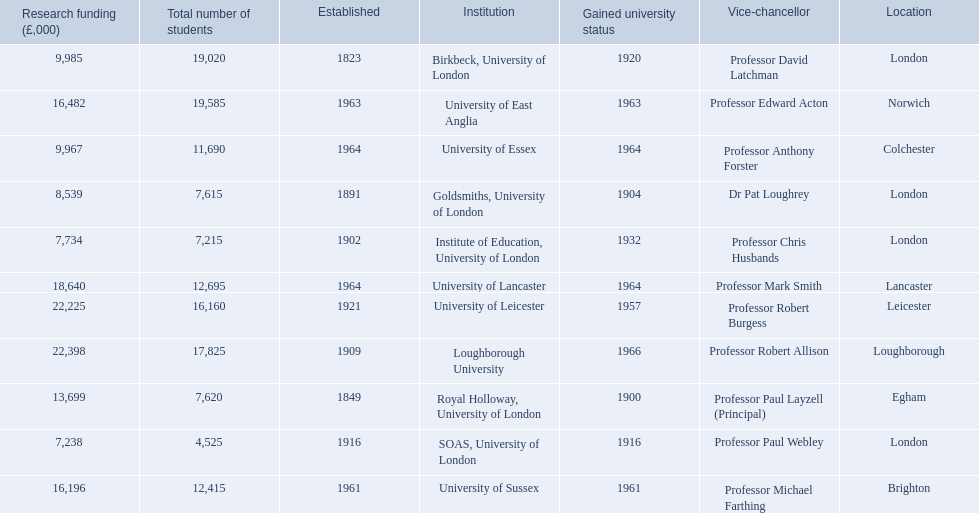What are the institutions in the 1994 group? Birkbeck, University of London, University of East Anglia, University of Essex, Goldsmiths, University of London, Institute of Education, University of London, University of Lancaster, University of Leicester, Loughborough University, Royal Holloway, University of London, SOAS, University of London, University of Sussex. Parse the full table in json format. {'header': ['Research funding (£,000)', 'Total number of students', 'Established', 'Institution', 'Gained university status', 'Vice-chancellor', 'Location'], 'rows': [['9,985', '19,020', '1823', 'Birkbeck, University of London', '1920', 'Professor David Latchman', 'London'], ['16,482', '19,585', '1963', 'University of East Anglia', '1963', 'Professor Edward Acton', 'Norwich'], ['9,967', '11,690', '1964', 'University of Essex', '1964', 'Professor Anthony Forster', 'Colchester'], ['8,539', '7,615', '1891', 'Goldsmiths, University of London', '1904', 'Dr Pat Loughrey', 'London'], ['7,734', '7,215', '1902', 'Institute of Education, University of London', '1932', 'Professor Chris Husbands', 'London'], ['18,640', '12,695', '1964', 'University of Lancaster', '1964', 'Professor Mark Smith', 'Lancaster'], ['22,225', '16,160', '1921', 'University of Leicester', '1957', 'Professor Robert Burgess', 'Leicester'], ['22,398', '17,825', '1909', 'Loughborough University', '1966', 'Professor Robert Allison', 'Loughborough'], ['13,699', '7,620', '1849', 'Royal Holloway, University of London', '1900', 'Professor Paul Layzell (Principal)', 'Egham'], ['7,238', '4,525', '1916', 'SOAS, University of London', '1916', 'Professor Paul Webley', 'London'], ['16,196', '12,415', '1961', 'University of Sussex', '1961', 'Professor Michael Farthing', 'Brighton']]} Which of these was made a university most recently? Loughborough University. 